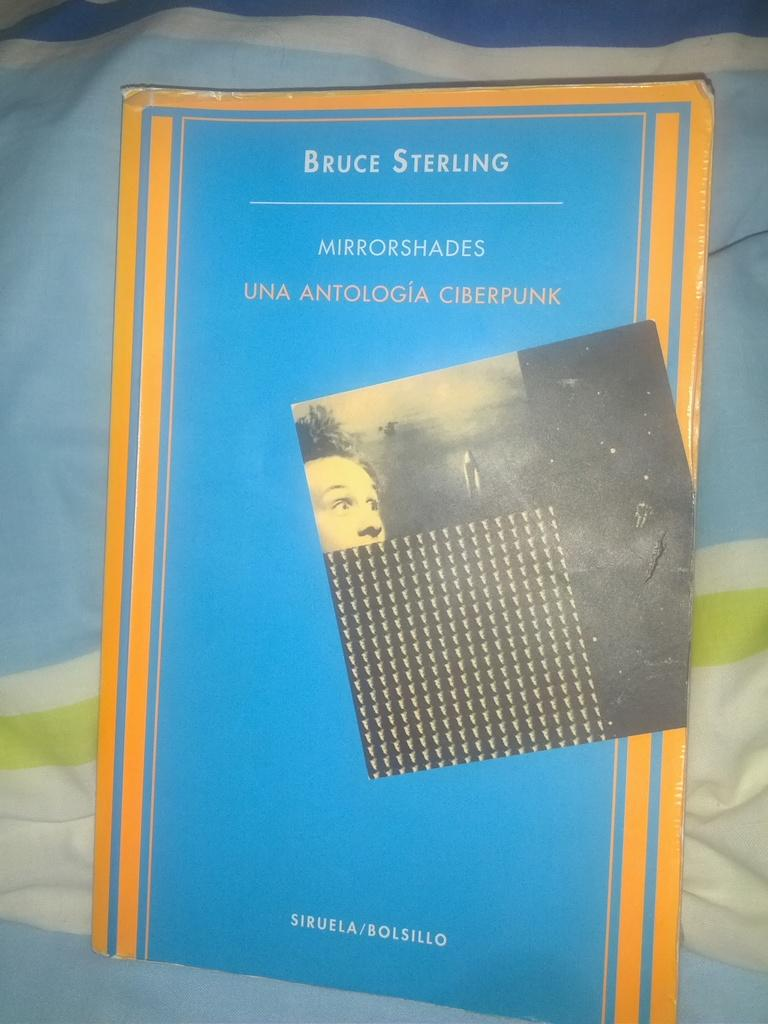<image>
Offer a succinct explanation of the picture presented. A small booklet by Bruce Sterling has a blue cover. 